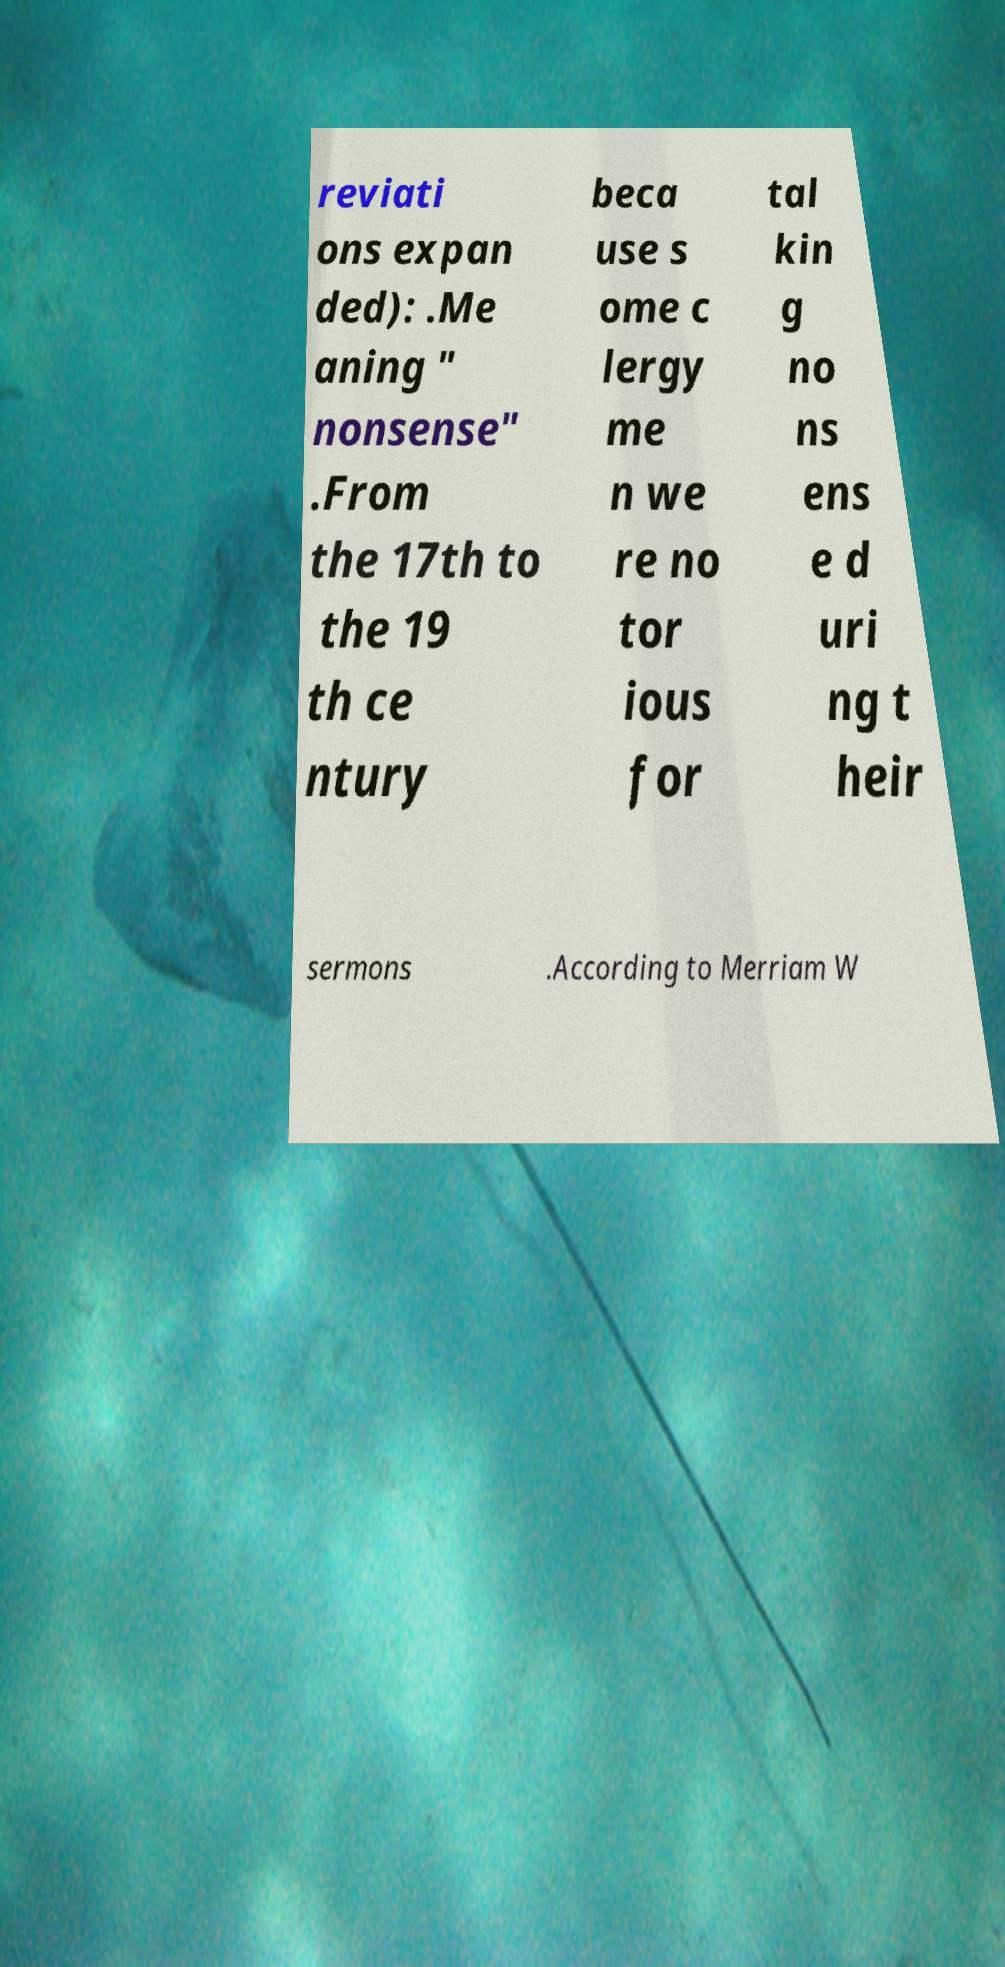Please identify and transcribe the text found in this image. reviati ons expan ded): .Me aning " nonsense" .From the 17th to the 19 th ce ntury beca use s ome c lergy me n we re no tor ious for tal kin g no ns ens e d uri ng t heir sermons .According to Merriam W 